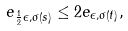<formula> <loc_0><loc_0><loc_500><loc_500>e _ { \frac { 1 } { 2 } \epsilon , \sigma ( s ) } \leq 2 e _ { \epsilon , \sigma ( t ) } ,</formula> 